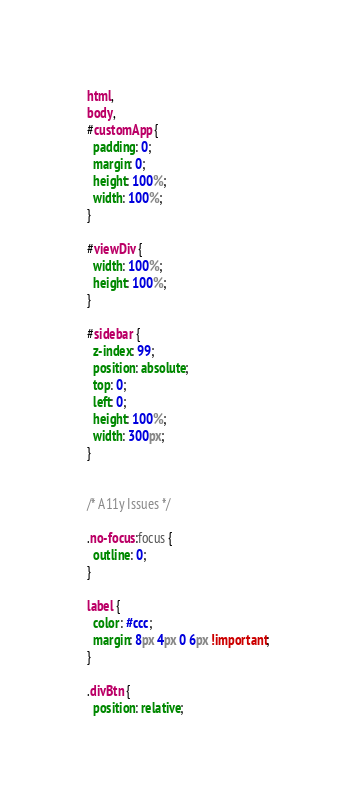Convert code to text. <code><loc_0><loc_0><loc_500><loc_500><_CSS_>html,
body,
#customApp {
  padding: 0;
  margin: 0;
  height: 100%;
  width: 100%;
}

#viewDiv {
  width: 100%;
  height: 100%;
}

#sidebar {
  z-index: 99;
  position: absolute;
  top: 0;
  left: 0;
  height: 100%;
  width: 300px;
}


/* A11y Issues */

.no-focus:focus {
  outline: 0;
}

label {
  color: #ccc;
  margin: 8px 4px 0 6px !important;
}

.divBtn {
  position: relative;</code> 